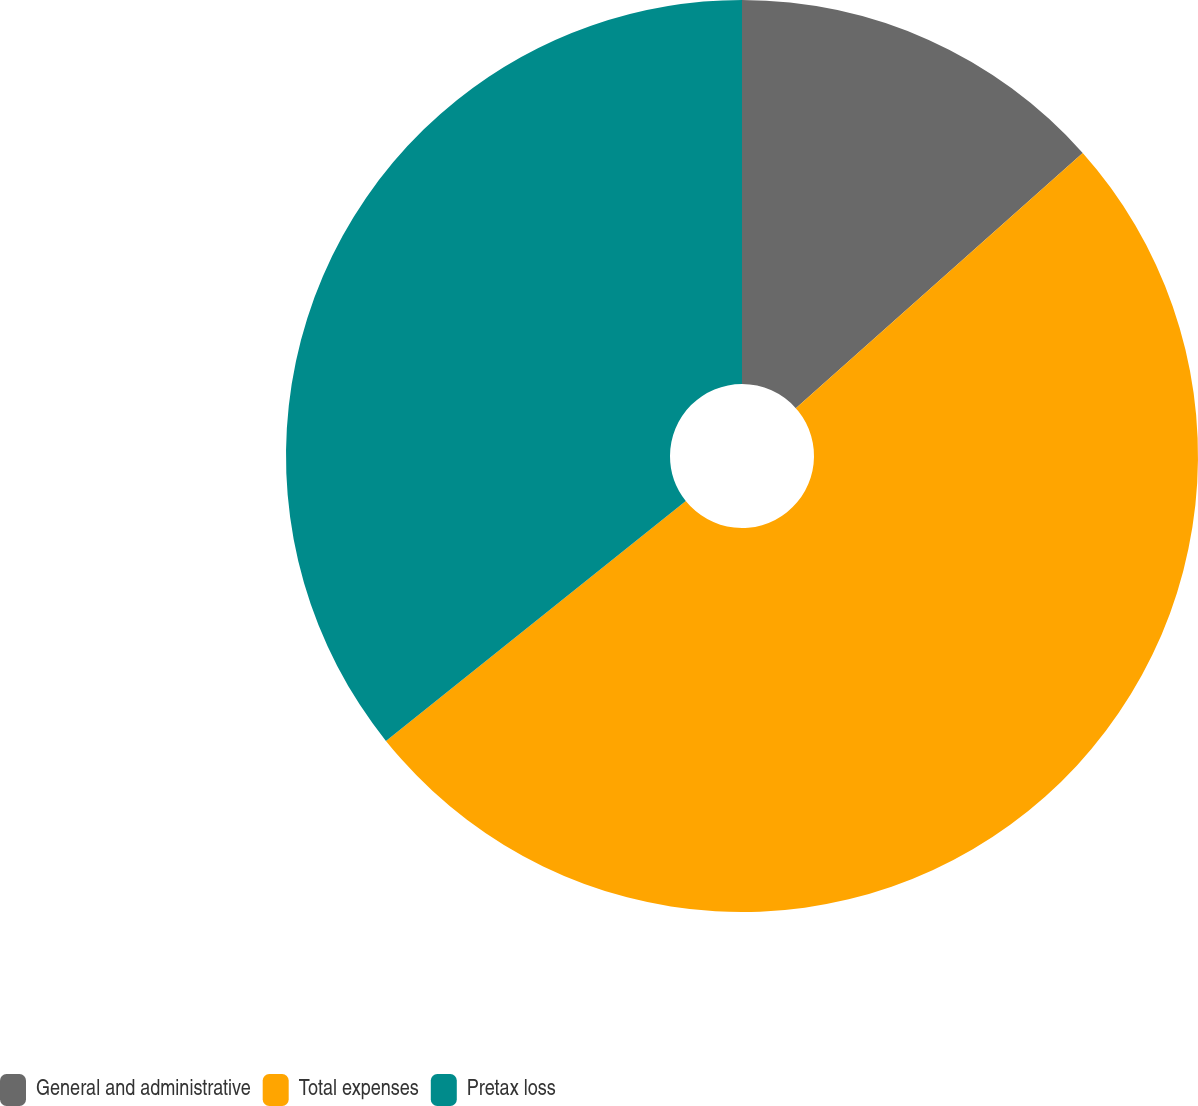<chart> <loc_0><loc_0><loc_500><loc_500><pie_chart><fcel>General and administrative<fcel>Total expenses<fcel>Pretax loss<nl><fcel>13.43%<fcel>50.83%<fcel>35.74%<nl></chart> 